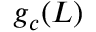<formula> <loc_0><loc_0><loc_500><loc_500>g _ { c } ( L )</formula> 